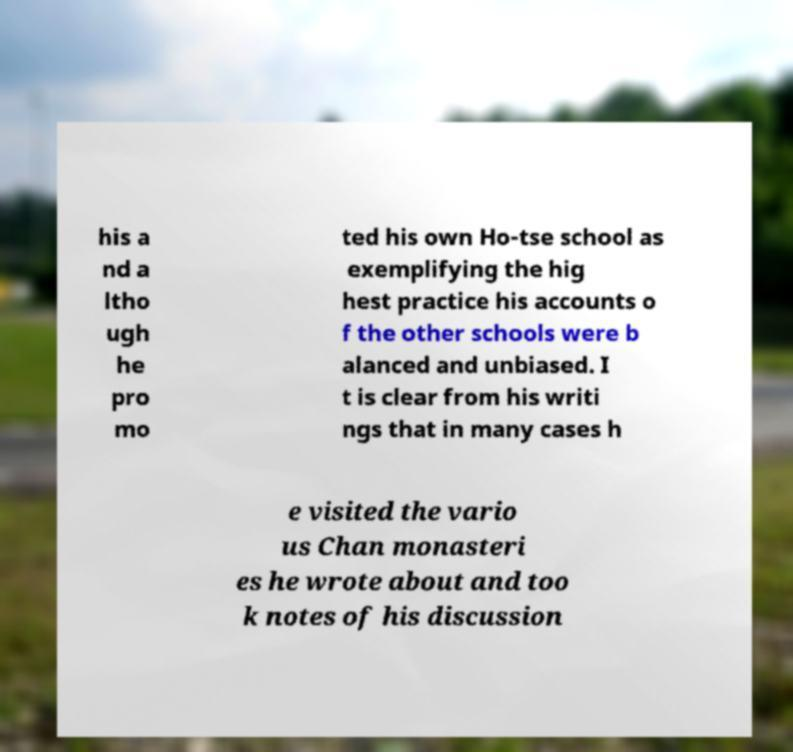Please identify and transcribe the text found in this image. his a nd a ltho ugh he pro mo ted his own Ho-tse school as exemplifying the hig hest practice his accounts o f the other schools were b alanced and unbiased. I t is clear from his writi ngs that in many cases h e visited the vario us Chan monasteri es he wrote about and too k notes of his discussion 